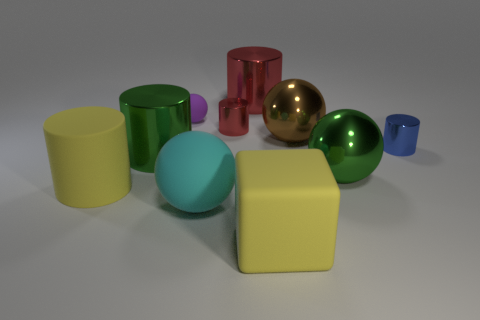Is the color of the matte block the same as the rubber cylinder?
Offer a terse response. Yes. Do the green shiny object to the right of the cyan rubber sphere and the small purple matte thing have the same shape?
Your answer should be very brief. Yes. How many big matte things are behind the yellow matte block and in front of the large yellow rubber cylinder?
Make the answer very short. 1. What material is the big red cylinder?
Provide a succinct answer. Metal. Are there any other things that have the same color as the big rubber block?
Keep it short and to the point. Yes. Is the big cyan object made of the same material as the tiny sphere?
Your answer should be very brief. Yes. What number of purple rubber things are in front of the metal cylinder to the left of the small cylinder that is left of the blue metal object?
Your answer should be very brief. 0. How many large brown metallic blocks are there?
Your response must be concise. 0. Is the number of small purple rubber objects in front of the big yellow matte cylinder less than the number of small blue cylinders that are right of the big matte block?
Provide a succinct answer. Yes. Are there fewer brown metal balls left of the big red thing than green cylinders?
Ensure brevity in your answer.  Yes. 